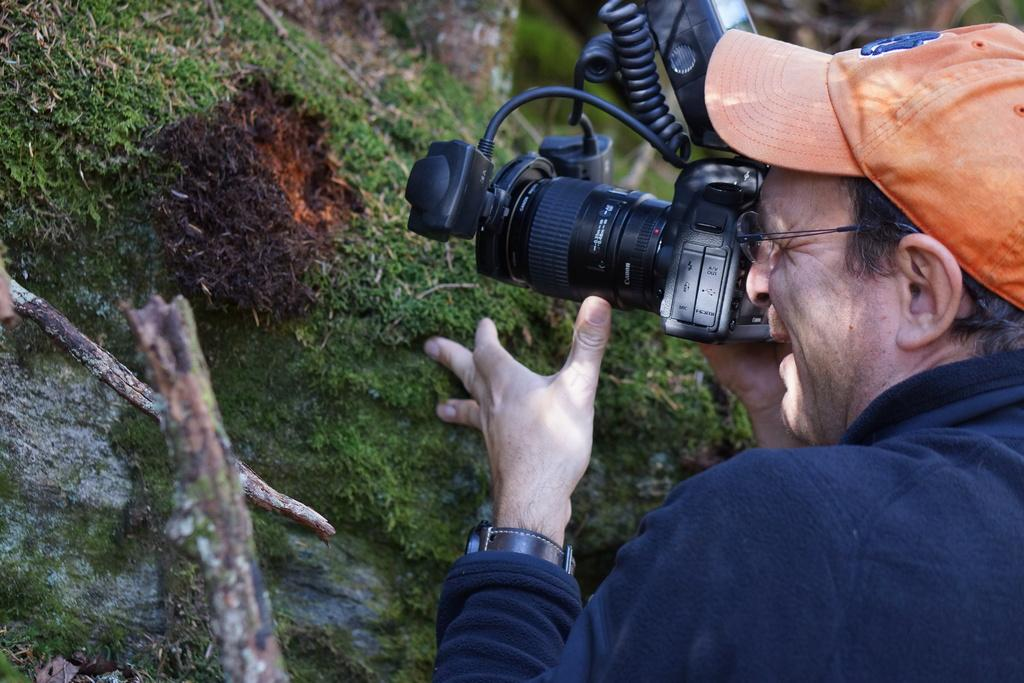What is present in the image? There is a person in the image. Can you describe the person's attire? The person is wearing a hat. What is the person holding in the image? The person is holding a camera. What type of magic is the person performing in the image? There is no indication of magic or any magical activity in the image. 